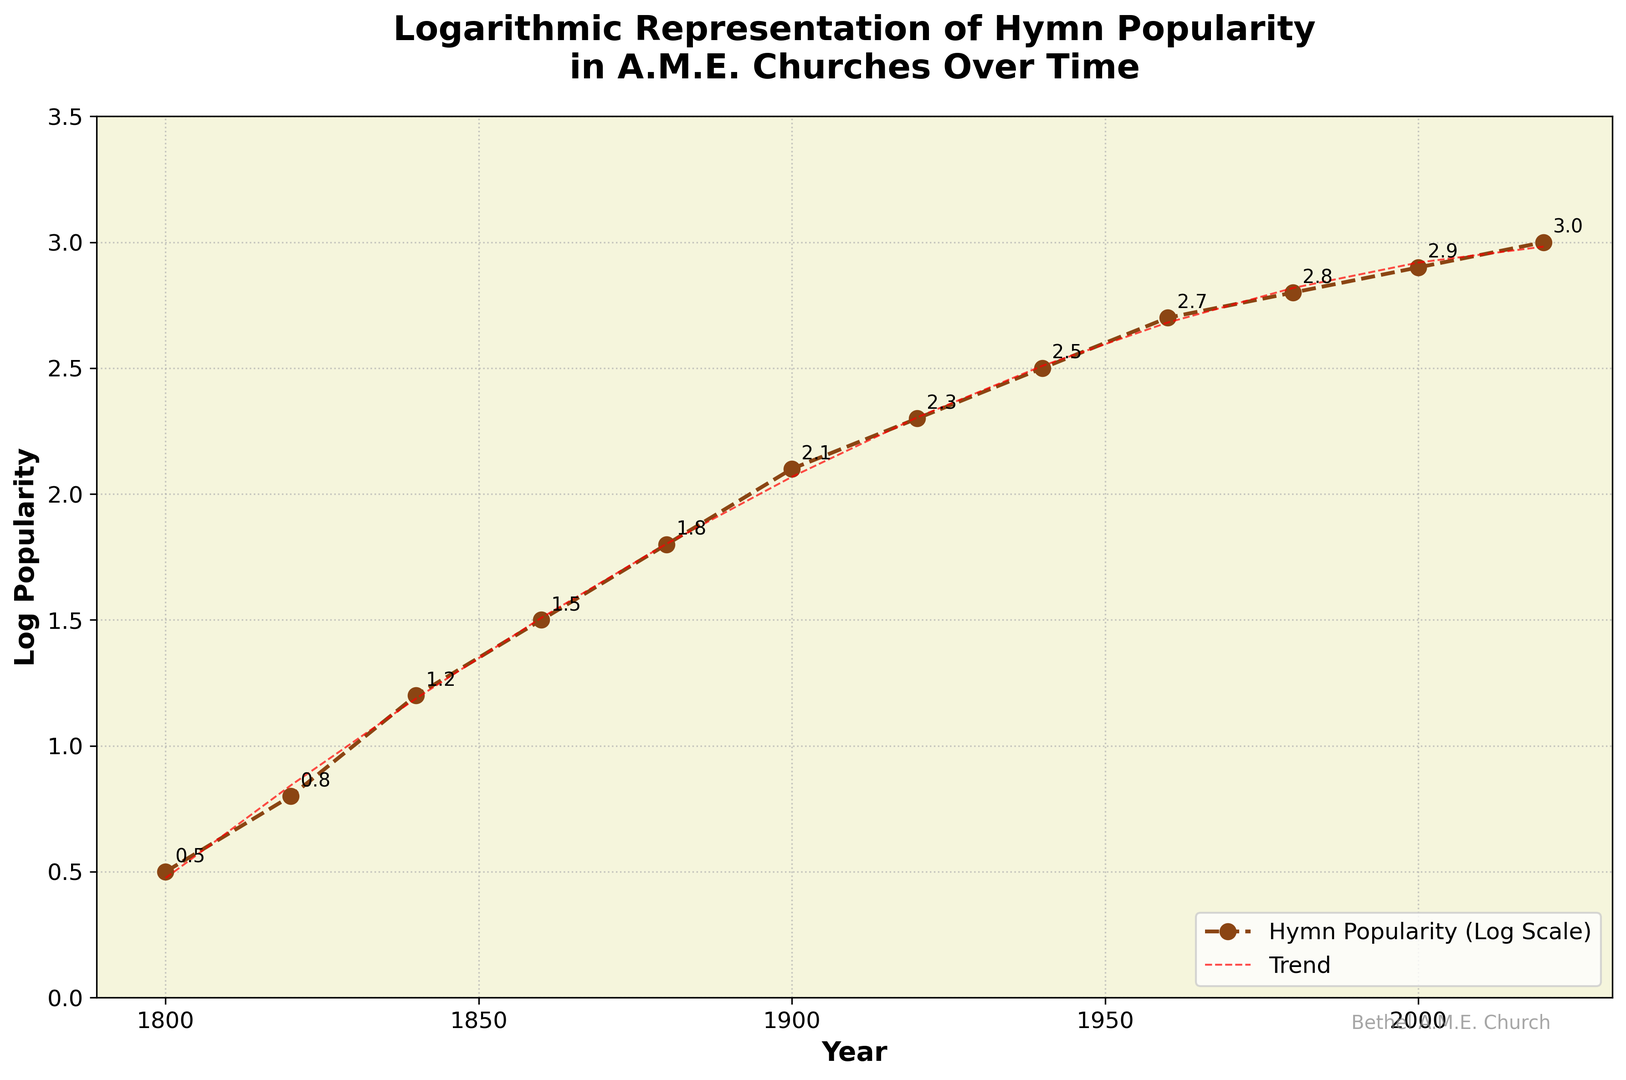What is the Log Popularity of hymns in the year 1860? Find the point corresponding to the year 1860 on the x-axis and read the value on the y-axis. The Log Popularity is marked as 1.5.
Answer: 1.5 How does the Log Popularity in 1940 compare to that in 1980? Locate the points for the years 1940 and 1980 on the x-axis and compare their y-axis values, which are 2.5 for 1940 and 2.8 for 1980. Therefore, the Log Popularity in 1980 is higher than in 1940.
Answer: 1980 is higher Which year shows the highest Log Popularity of hymns? Follow the trendline and identify the highest point on the y-axis. The maximum Log Popularity value is 3.0 in the year 2020.
Answer: 2020 What is the overall trend in hymn popularity from 1800 to 2020? Observe the slope of the plotted line from 1800 to 2020. The Log Popularity values show a generally increasing trend throughout the years.
Answer: Increasing Identify the period with the steepest increase in Log Popularity. Examine the slopes of the segments between data points. The steepest increase appears between 1840 and 1860, where the popularity grows from 1.2 to 1.5.
Answer: 1840-1860 What is the average Log Popularity of hymns for the years 1900, 1920, and 1940? The Log Popularity values for 1900, 1920, and 1940 are 2.1, 2.3, and 2.5 respectively. Sum these values (2.1 + 2.3 + 2.5 = 6.9) and divide by the number of years (6.9/3 = 2.3).
Answer: 2.3 Describe the color and style of the trend line. The trend line is represented as a red dashed line.
Answer: Red dashed line What is the change in Log Popularity from 2000 to 2020? Find the Log Popularity values for the years 2000 and 2020, which are 2.9 and 3.0 respectively. Subtract the value of 2000 from 2020 (3.0 - 2.9 = 0.1).
Answer: 0.1 Between which two consecutive periods did the Log Popularity remain the most stable? Compare the differences between consecutive Log Popularity values. The least change is observed between 1980 and 2000, where the change is 0.2 (2.8 to 2.9).
Answer: 1980-2000 